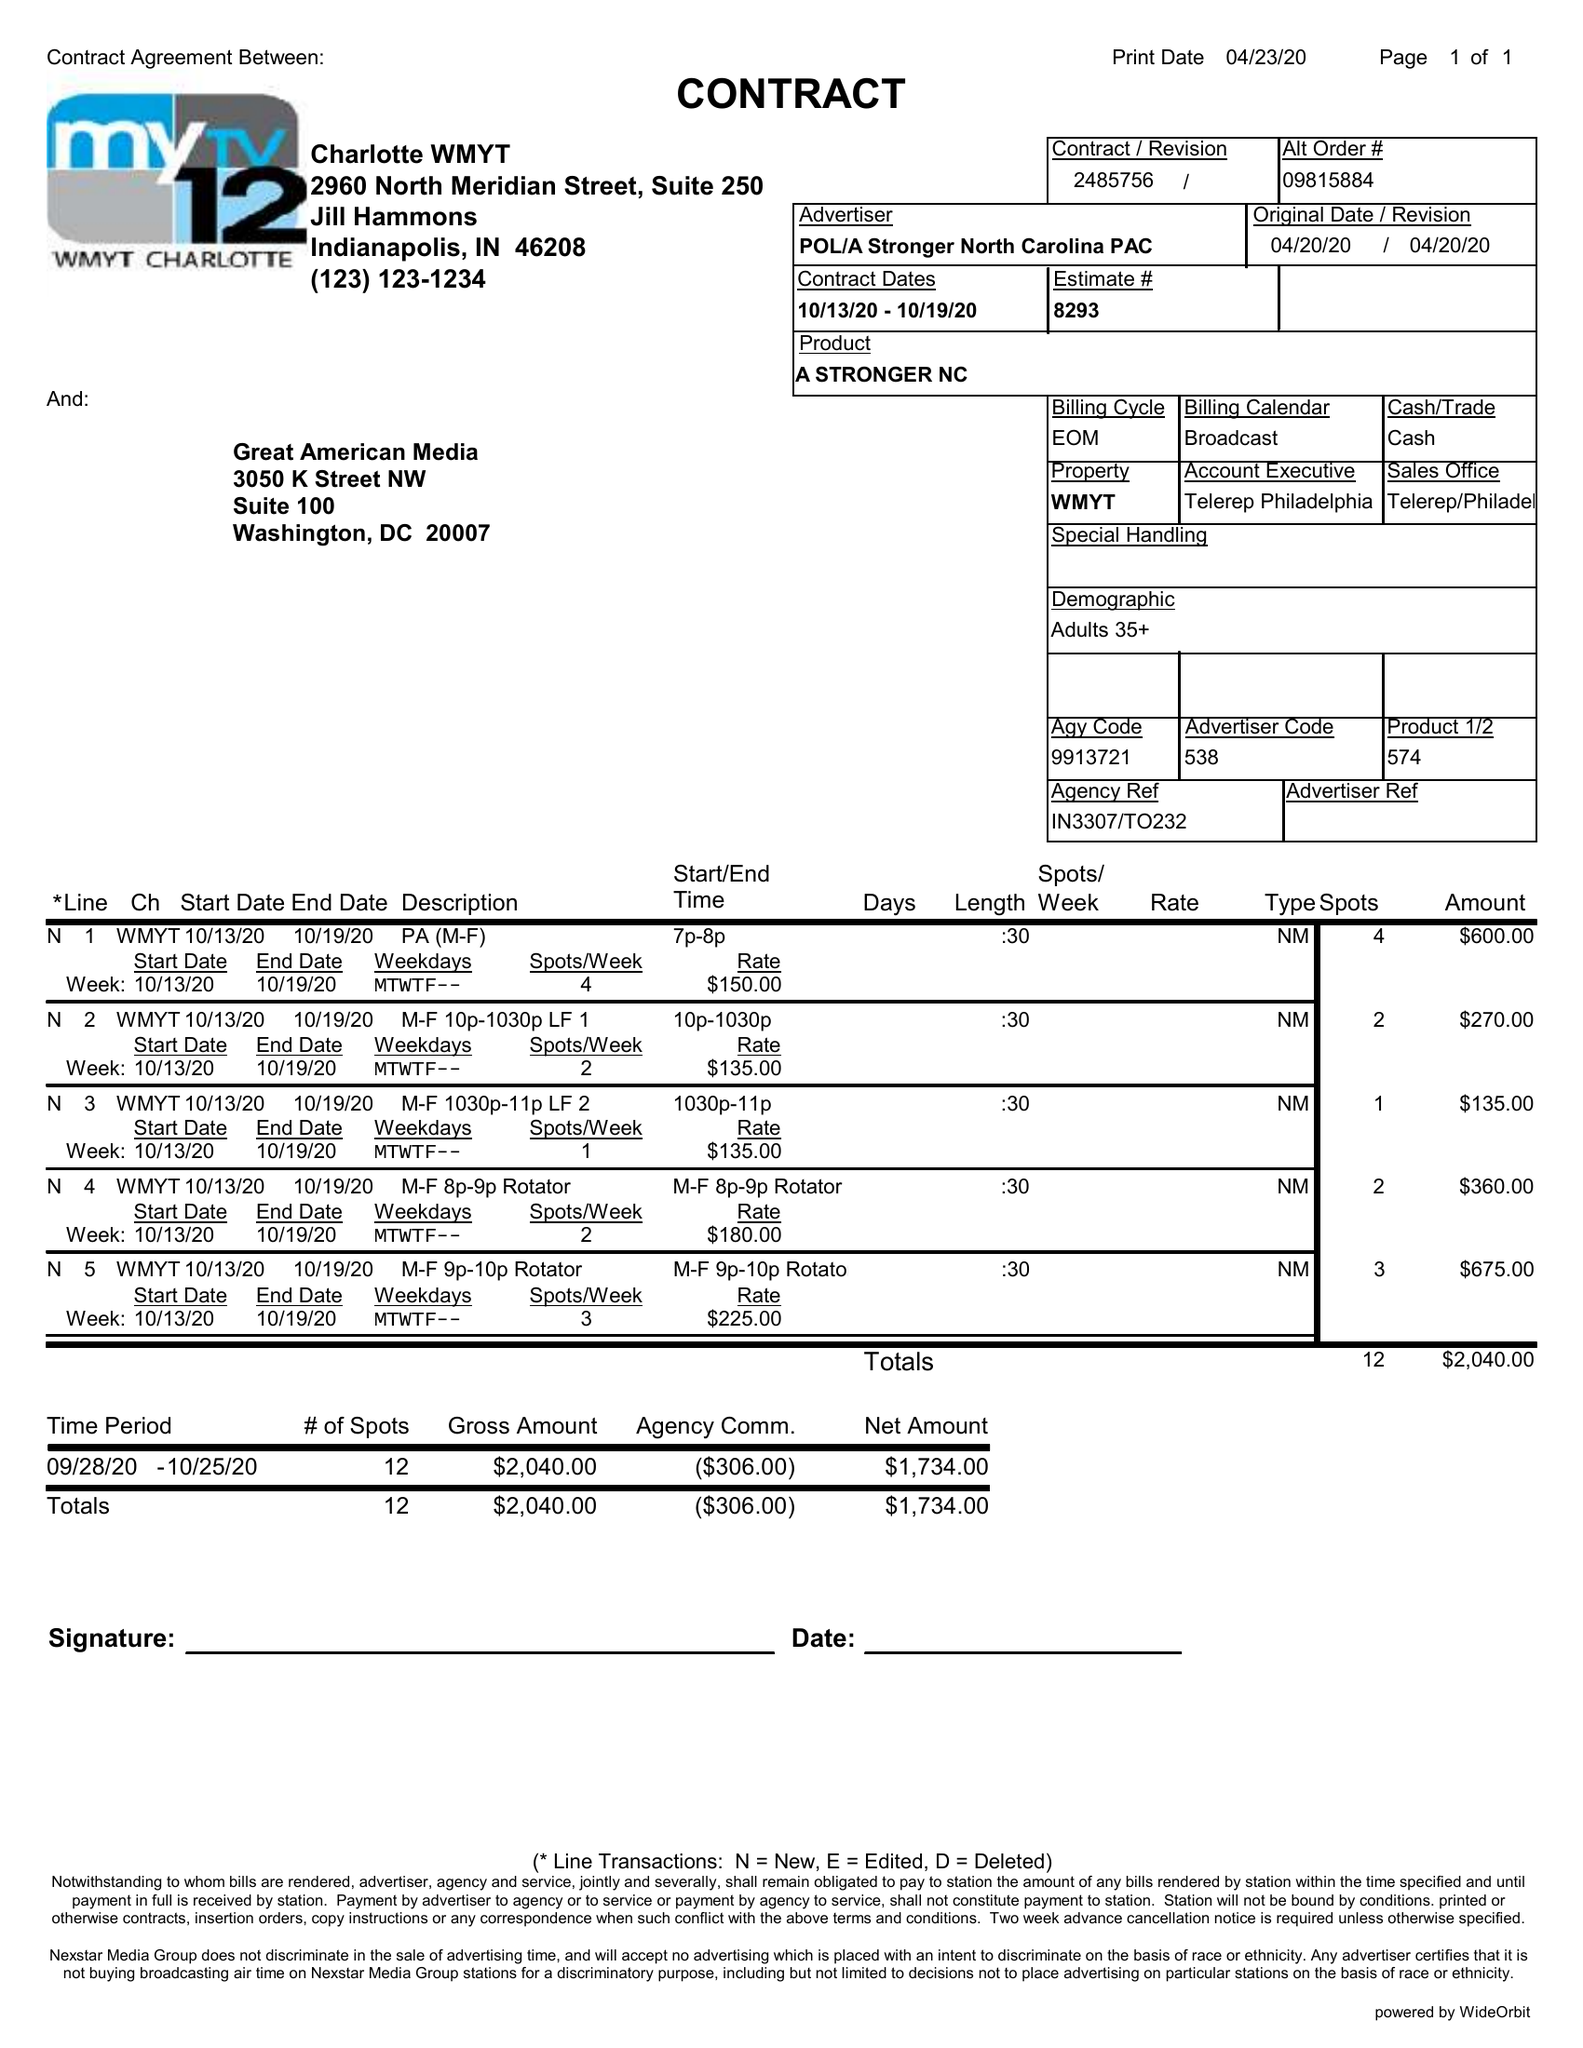What is the value for the advertiser?
Answer the question using a single word or phrase. POL/ASTRONGERNORTHCAROLINAPAC 